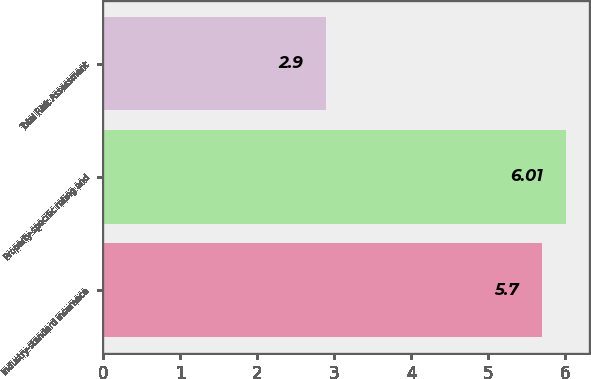Convert chart. <chart><loc_0><loc_0><loc_500><loc_500><bar_chart><fcel>Industry-standard insurance<fcel>Property-specific rating and<fcel>Total Risk Assessment<nl><fcel>5.7<fcel>6.01<fcel>2.9<nl></chart> 